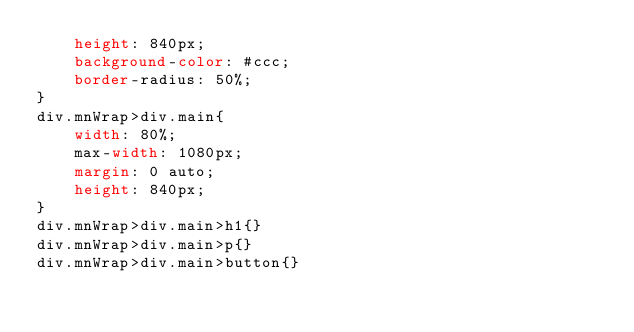<code> <loc_0><loc_0><loc_500><loc_500><_CSS_>    height: 840px;
    background-color: #ccc;
    border-radius: 50%;
}
div.mnWrap>div.main{
    width: 80%;
    max-width: 1080px;
    margin: 0 auto;
    height: 840px;
}
div.mnWrap>div.main>h1{}
div.mnWrap>div.main>p{}
div.mnWrap>div.main>button{}</code> 